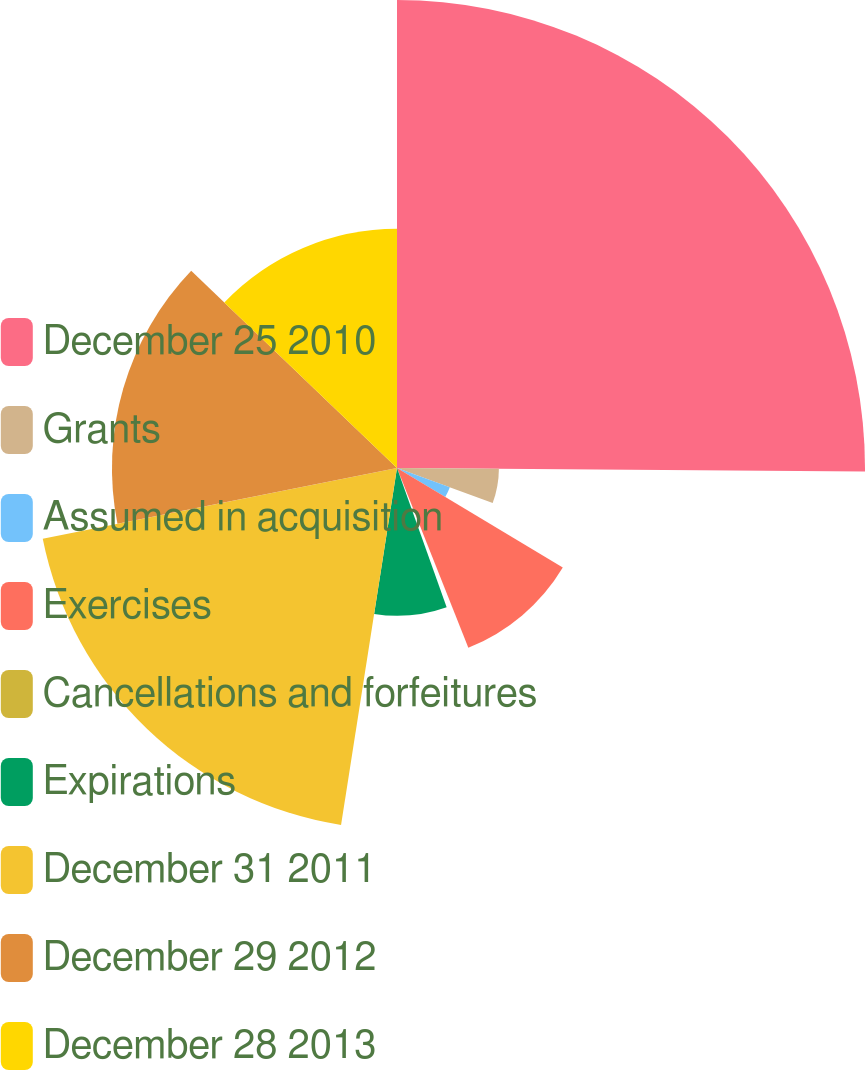Convert chart. <chart><loc_0><loc_0><loc_500><loc_500><pie_chart><fcel>December 25 2010<fcel>Grants<fcel>Assumed in acquisition<fcel>Exercises<fcel>Cancellations and forfeitures<fcel>Expirations<fcel>December 31 2011<fcel>December 29 2012<fcel>December 28 2013<nl><fcel>25.12%<fcel>5.47%<fcel>3.02%<fcel>10.38%<fcel>0.56%<fcel>7.93%<fcel>19.39%<fcel>15.3%<fcel>12.84%<nl></chart> 